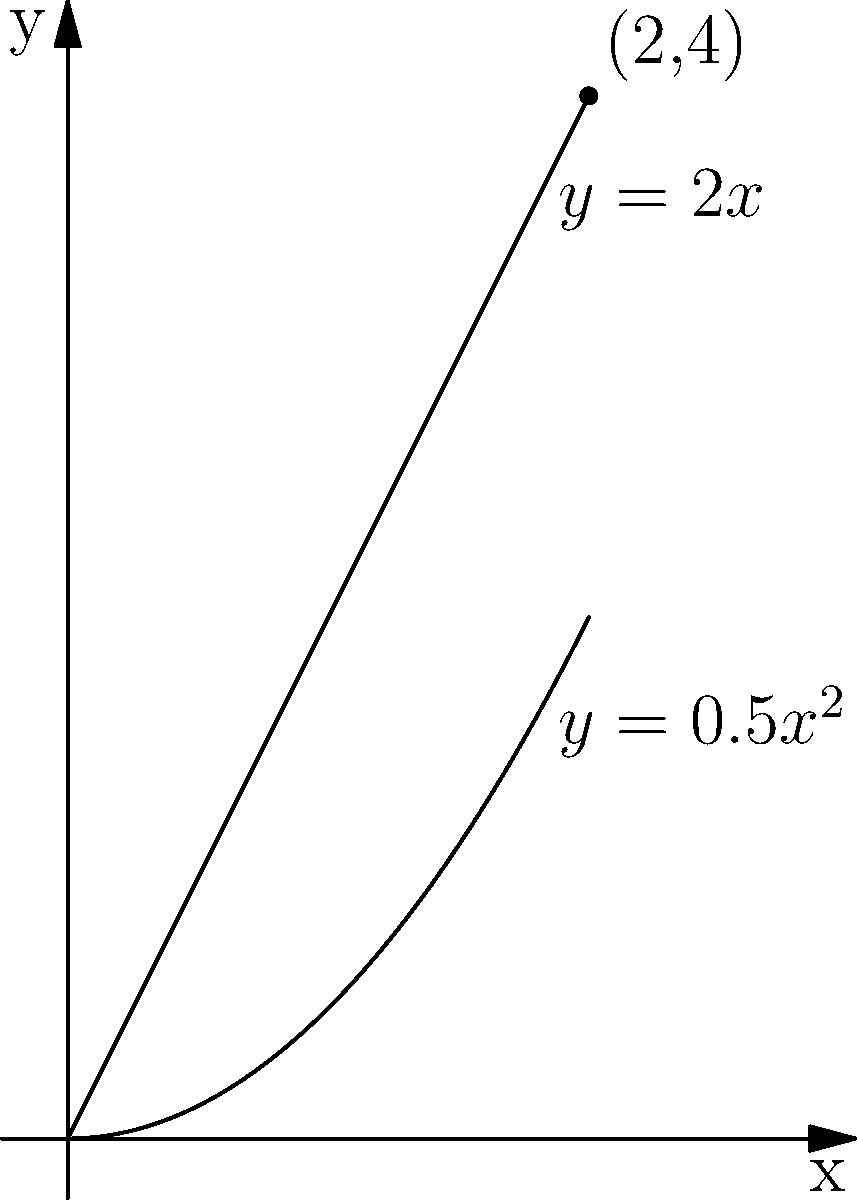As a scuba diving enthusiast, you're designing a new diving fin shape. The cross-section of the fin can be modeled by the region bounded by the curves $y=0.5x^2$ and $y=2x$ for $0 \leq x \leq 2$. To optimize the fin's performance, you need to find the area of this cross-section. Calculate the area of the region bounded by these curves. Let's approach this step-by-step:

1) The area between two curves is given by the integral of the difference between the upper and lower functions:

   $A = \int_{a}^{b} [f(x) - g(x)] dx$

   where $f(x)$ is the upper function and $g(x)$ is the lower function.

2) In this case, for $0 \leq x \leq 2$:
   Upper function: $f(x) = 2x$
   Lower function: $g(x) = 0.5x^2$

3) Set up the integral:

   $A = \int_{0}^{2} [2x - 0.5x^2] dx$

4) Integrate:

   $A = [2x^2/2 - 0.5x^3/3]_0^2$

5) Evaluate the bounds:

   $A = [(2^2) - (0.5*2^3/3)] - [0 - 0]$
   $A = [4 - 4/3] - 0$
   $A = 4 - 4/3$
   $A = 12/3 - 4/3$
   $A = 8/3$

Therefore, the area of the cross-section is $8/3$ square units.
Answer: $\frac{8}{3}$ square units 